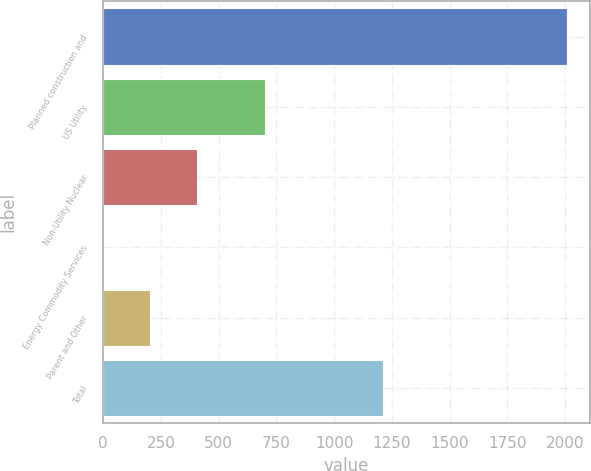Convert chart. <chart><loc_0><loc_0><loc_500><loc_500><bar_chart><fcel>Planned construction and<fcel>US Utility<fcel>Non-Utility Nuclear<fcel>Energy Commodity Services<fcel>Parent and Other<fcel>Total<nl><fcel>2006<fcel>699<fcel>404.4<fcel>4<fcel>204.2<fcel>1210<nl></chart> 